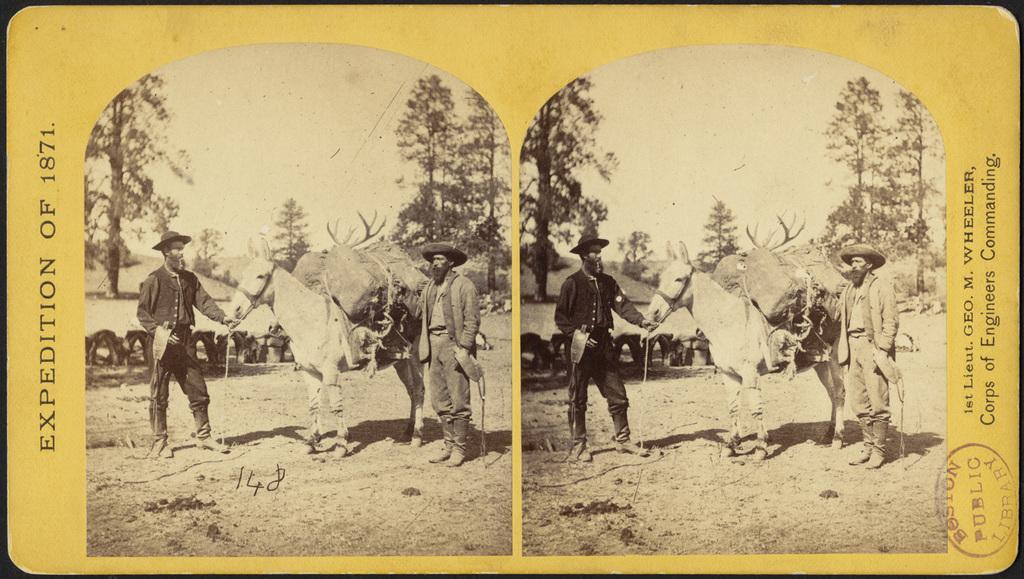Can you describe this image briefly? In this picture i can see two photos in this pad. In that photo i can see two persons were standing near to the horse. In the horse's back i can see some jute-bag. In the background i can see trees, plants, shed and sky. On the right there is a quotation. In the bottom right corner there is a watermark. 